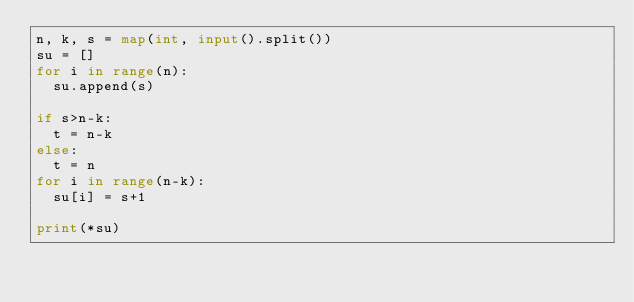<code> <loc_0><loc_0><loc_500><loc_500><_Python_>n, k, s = map(int, input().split()) 
su = []
for i in range(n):
  su.append(s)

if s>n-k:
  t = n-k
else:
  t = n
for i in range(n-k):
  su[i] = s+1

print(*su)
    </code> 